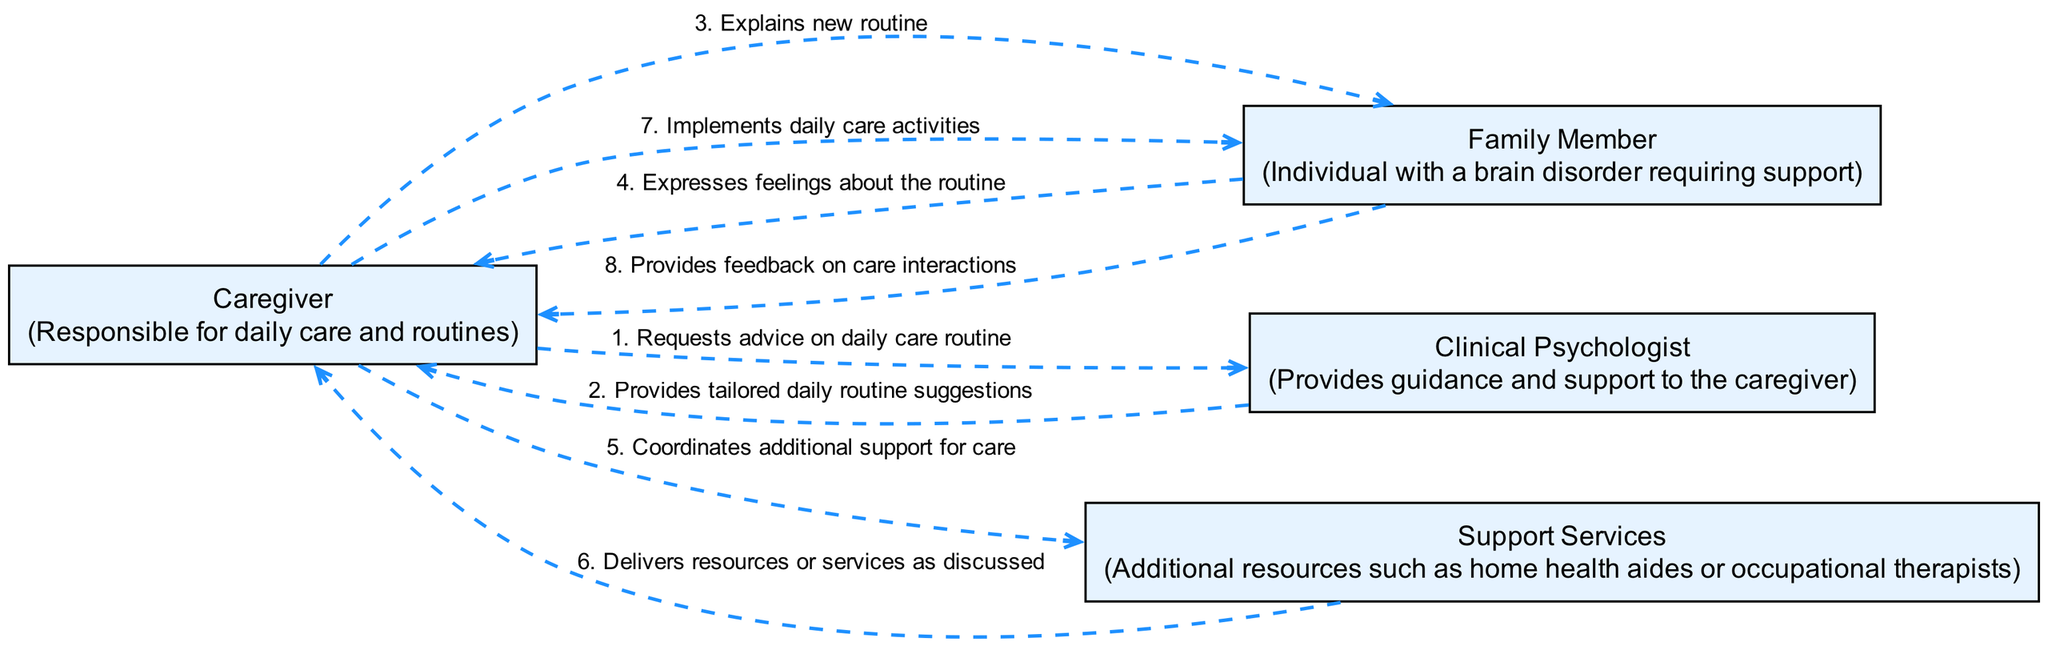What are the participants in the diagram? The diagram includes four participants: Caregiver, Family Member, Clinical Psychologist, and Support Services. Each participant's role is defined, providing context to their interactions.
Answer: Caregiver, Family Member, Clinical Psychologist, Support Services How many interactions are there in the diagram? By counting all specified interactions among the participants, there are a total of eight distinct interactions indicated within the flow of the diagram.
Answer: 8 Who initially communicates with the Clinical Psychologist? The diagram shows that the Caregiver is the one who first reaches out to the Clinical Psychologist to request advice on the daily care routine.
Answer: Caregiver What does the Clinical Psychologist provide to the Caregiver? The Clinical Psychologist responds to the Caregiver's request by providing tailored daily routine suggestions, which are critical for the Caregiver's planning.
Answer: Tailored daily routine suggestions What is the second interaction that occurs in the sequence? The second interaction is between the Clinical Psychologist and the Caregiver, where the Clinical Psychologist provides advice after the Caregiver's request. Following the numbering in the diagram, this is the second action elaborated.
Answer: Provides tailored daily routine suggestions Which participant expresses feelings about the routine, and to whom? The Family Member expresses feelings about the new routine to the Caregiver, highlighting the Family Member's emotional engagement in the process.
Answer: Family Member to Caregiver What does the Caregiver do after explaining the new routine to the Family Member? After explaining the new routine, the Caregiver implements daily care activities, actively engaging in the caregiving process as planned.
Answer: Implements daily care activities From whom does the Caregiver receive resources or services? The Caregiver receives resources or services from Support Services, confirming their role in assisting with additional care needs as discussed earlier.
Answer: Support Services 